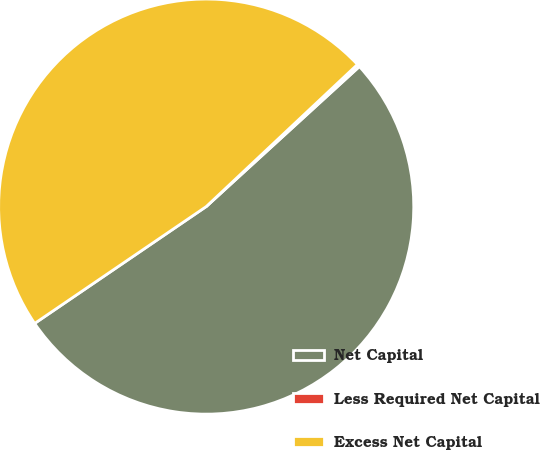Convert chart. <chart><loc_0><loc_0><loc_500><loc_500><pie_chart><fcel>Net Capital<fcel>Less Required Net Capital<fcel>Excess Net Capital<nl><fcel>52.27%<fcel>0.22%<fcel>47.51%<nl></chart> 